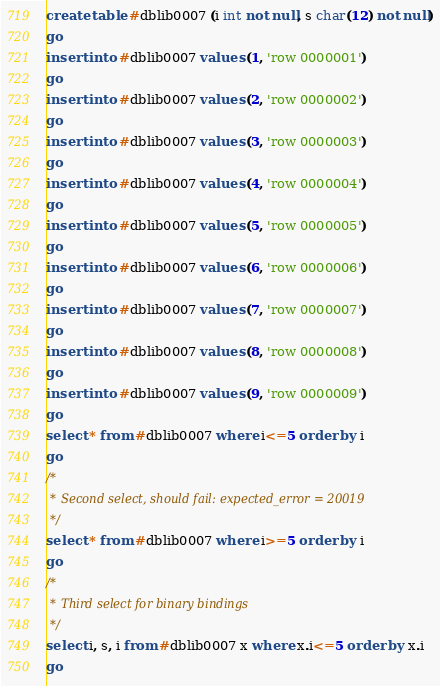Convert code to text. <code><loc_0><loc_0><loc_500><loc_500><_SQL_>create table #dblib0007 (i int not null, s char(12) not null)
go
insert into #dblib0007 values (1, 'row 0000001')
go
insert into #dblib0007 values (2, 'row 0000002')
go
insert into #dblib0007 values (3, 'row 0000003')
go
insert into #dblib0007 values (4, 'row 0000004')
go
insert into #dblib0007 values (5, 'row 0000005')
go
insert into #dblib0007 values (6, 'row 0000006')
go
insert into #dblib0007 values (7, 'row 0000007')
go
insert into #dblib0007 values (8, 'row 0000008')
go
insert into #dblib0007 values (9, 'row 0000009')
go
select * from #dblib0007 where i<=5 order by i
go
/*
 * Second select, should fail: expected_error = 20019
 */
select * from #dblib0007 where i>=5 order by i
go
/*
 * Third select for binary bindings
 */
select i, s, i from #dblib0007 x where x.i<=5 order by x.i
go
</code> 